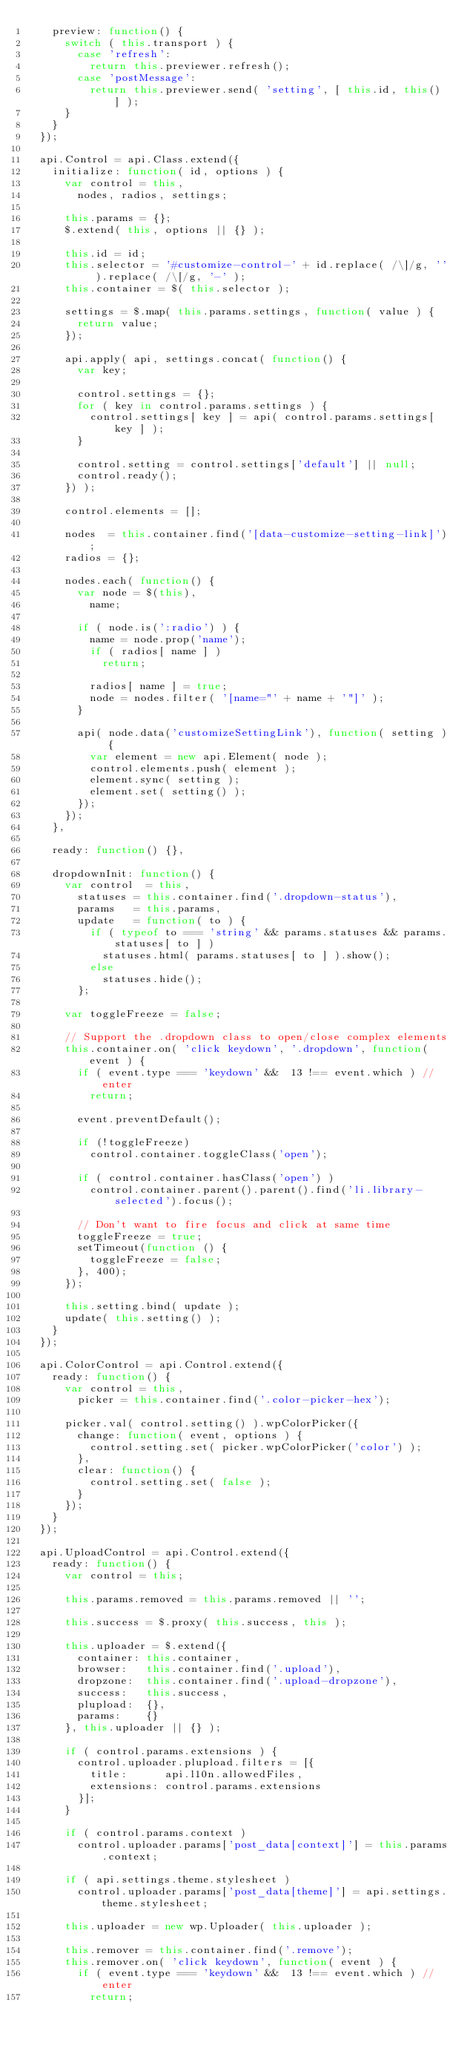Convert code to text. <code><loc_0><loc_0><loc_500><loc_500><_JavaScript_>		preview: function() {
			switch ( this.transport ) {
				case 'refresh':
					return this.previewer.refresh();
				case 'postMessage':
					return this.previewer.send( 'setting', [ this.id, this() ] );
			}
		}
	});

	api.Control = api.Class.extend({
		initialize: function( id, options ) {
			var control = this,
				nodes, radios, settings;

			this.params = {};
			$.extend( this, options || {} );

			this.id = id;
			this.selector = '#customize-control-' + id.replace( /\]/g, '' ).replace( /\[/g, '-' );
			this.container = $( this.selector );

			settings = $.map( this.params.settings, function( value ) {
				return value;
			});

			api.apply( api, settings.concat( function() {
				var key;

				control.settings = {};
				for ( key in control.params.settings ) {
					control.settings[ key ] = api( control.params.settings[ key ] );
				}

				control.setting = control.settings['default'] || null;
				control.ready();
			}) );

			control.elements = [];

			nodes  = this.container.find('[data-customize-setting-link]');
			radios = {};

			nodes.each( function() {
				var node = $(this),
					name;

				if ( node.is(':radio') ) {
					name = node.prop('name');
					if ( radios[ name ] )
						return;

					radios[ name ] = true;
					node = nodes.filter( '[name="' + name + '"]' );
				}

				api( node.data('customizeSettingLink'), function( setting ) {
					var element = new api.Element( node );
					control.elements.push( element );
					element.sync( setting );
					element.set( setting() );
				});
			});
		},

		ready: function() {},

		dropdownInit: function() {
			var control  = this,
				statuses = this.container.find('.dropdown-status'),
				params   = this.params,
				update   = function( to ) {
					if ( typeof	to === 'string' && params.statuses && params.statuses[ to ] )
						statuses.html( params.statuses[ to ] ).show();
					else
						statuses.hide();
				};

			var toggleFreeze = false;

			// Support the .dropdown class to open/close complex elements
			this.container.on( 'click keydown', '.dropdown', function( event ) {
				if ( event.type === 'keydown' &&  13 !== event.which ) // enter
					return;

				event.preventDefault();

				if (!toggleFreeze)
					control.container.toggleClass('open');

				if ( control.container.hasClass('open') )
					control.container.parent().parent().find('li.library-selected').focus();

				// Don't want to fire focus and click at same time
				toggleFreeze = true;
				setTimeout(function () {
					toggleFreeze = false;
				}, 400);
			});

			this.setting.bind( update );
			update( this.setting() );
		}
	});

	api.ColorControl = api.Control.extend({
		ready: function() {
			var control = this,
				picker = this.container.find('.color-picker-hex');

			picker.val( control.setting() ).wpColorPicker({
				change: function( event, options ) {
					control.setting.set( picker.wpColorPicker('color') );
 				},
 				clear: function() {
 					control.setting.set( false );
 				}
			});
		}
	});

	api.UploadControl = api.Control.extend({
		ready: function() {
			var control = this;

			this.params.removed = this.params.removed || '';

			this.success = $.proxy( this.success, this );

			this.uploader = $.extend({
				container: this.container,
				browser:   this.container.find('.upload'),
				dropzone:  this.container.find('.upload-dropzone'),
				success:   this.success,
				plupload:  {},
				params:    {}
			}, this.uploader || {} );

			if ( control.params.extensions ) {
				control.uploader.plupload.filters = [{
					title:      api.l10n.allowedFiles,
					extensions: control.params.extensions
				}];
			}

			if ( control.params.context )
				control.uploader.params['post_data[context]'] = this.params.context;

			if ( api.settings.theme.stylesheet )
				control.uploader.params['post_data[theme]'] = api.settings.theme.stylesheet;

			this.uploader = new wp.Uploader( this.uploader );

			this.remover = this.container.find('.remove');
			this.remover.on( 'click keydown', function( event ) {
				if ( event.type === 'keydown' &&  13 !== event.which ) // enter
					return;
</code> 